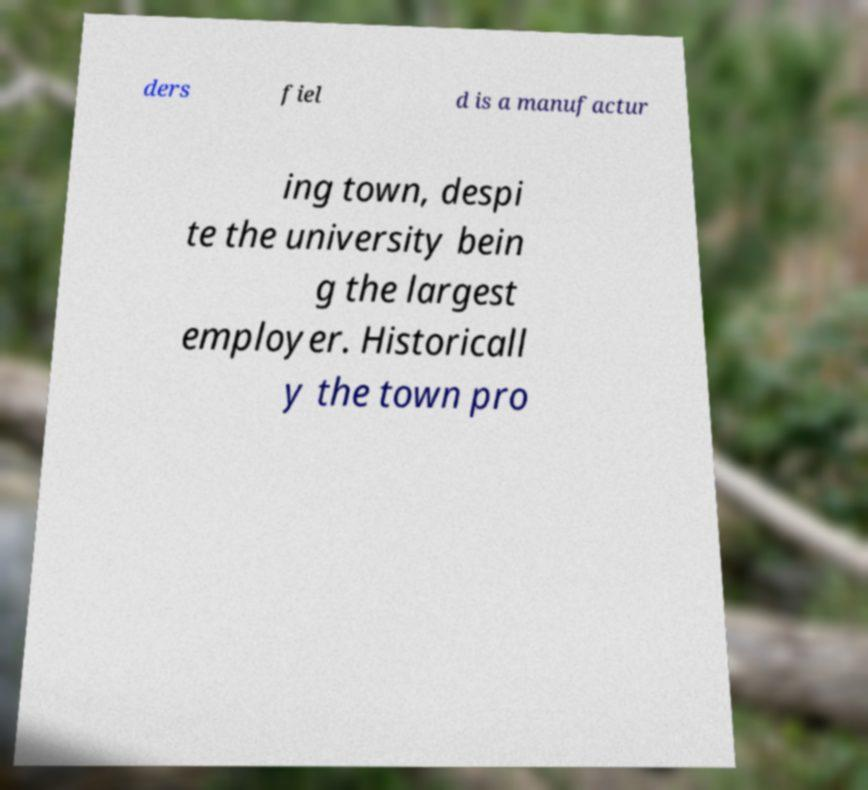I need the written content from this picture converted into text. Can you do that? ders fiel d is a manufactur ing town, despi te the university bein g the largest employer. Historicall y the town pro 